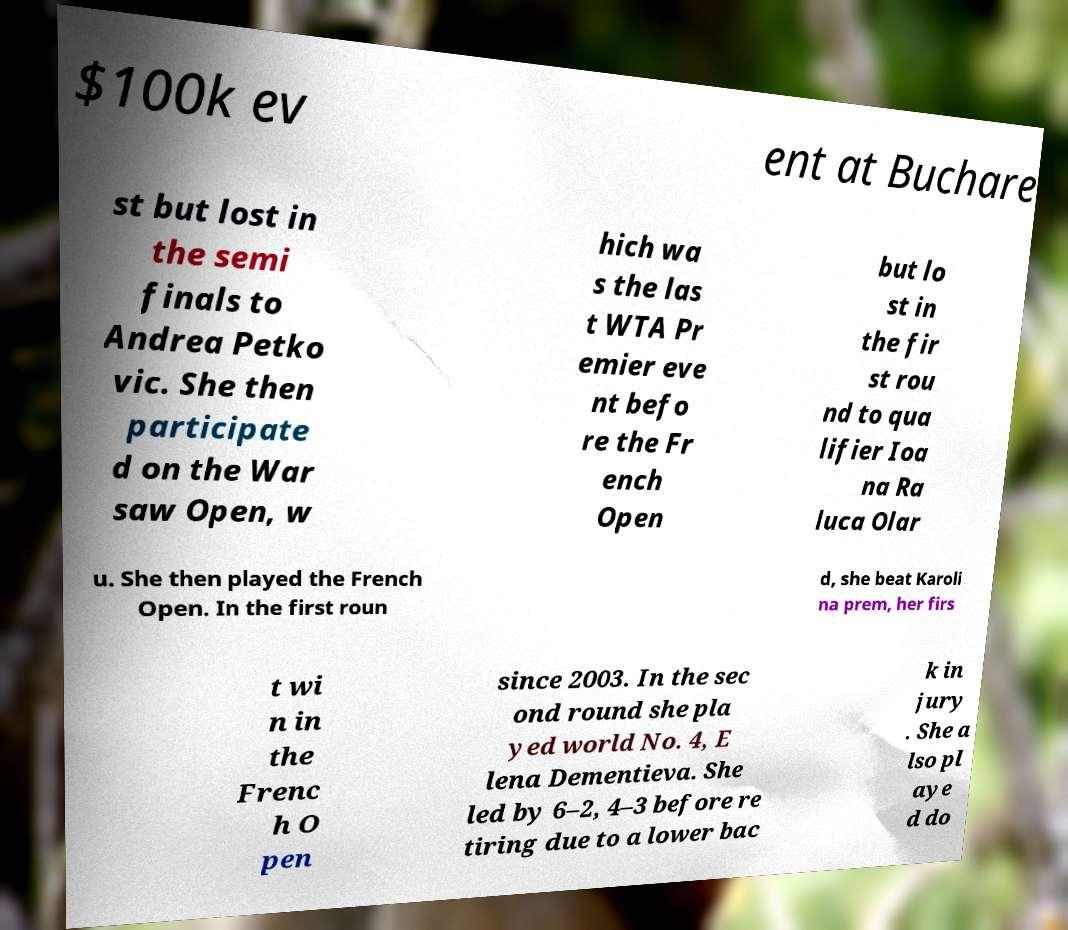I need the written content from this picture converted into text. Can you do that? $100k ev ent at Buchare st but lost in the semi finals to Andrea Petko vic. She then participate d on the War saw Open, w hich wa s the las t WTA Pr emier eve nt befo re the Fr ench Open but lo st in the fir st rou nd to qua lifier Ioa na Ra luca Olar u. She then played the French Open. In the first roun d, she beat Karoli na prem, her firs t wi n in the Frenc h O pen since 2003. In the sec ond round she pla yed world No. 4, E lena Dementieva. She led by 6–2, 4–3 before re tiring due to a lower bac k in jury . She a lso pl aye d do 